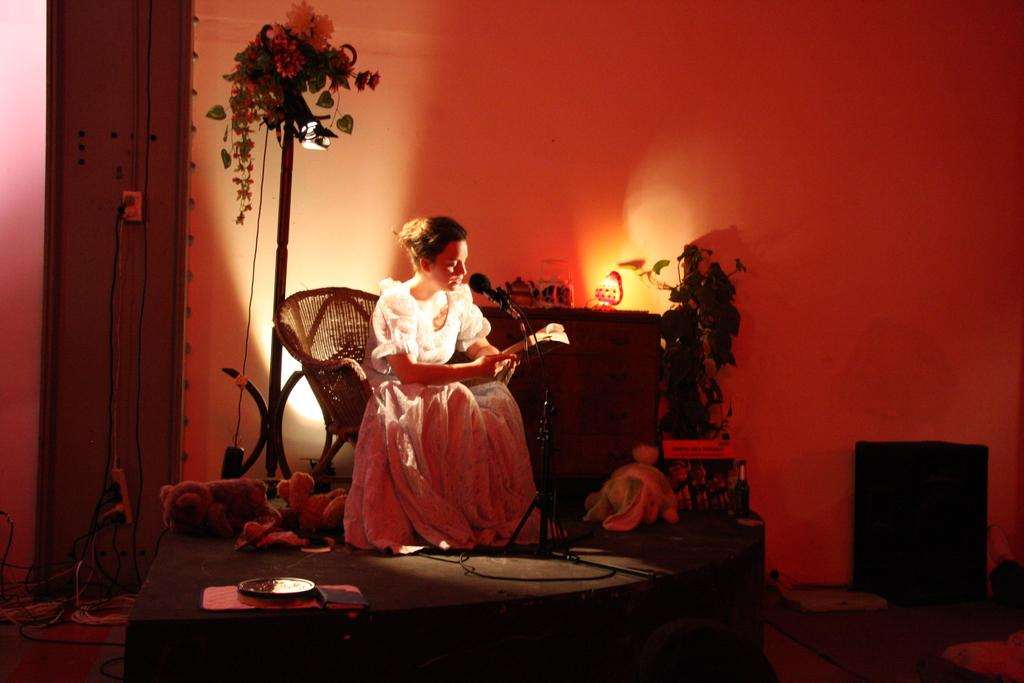Who is the main subject in the image? There is a woman in the image. What is the woman doing in the image? The woman is seated on a chair and holding a book in her hand. How is the woman communicating in the image? The woman is speaking with the help of a microphone. What can be seen in the background of the image? There are plants visible in the image. What type of scissors is the woman using to cut the book in the image? There is no scissors present in the image, and the woman is not cutting the book. 